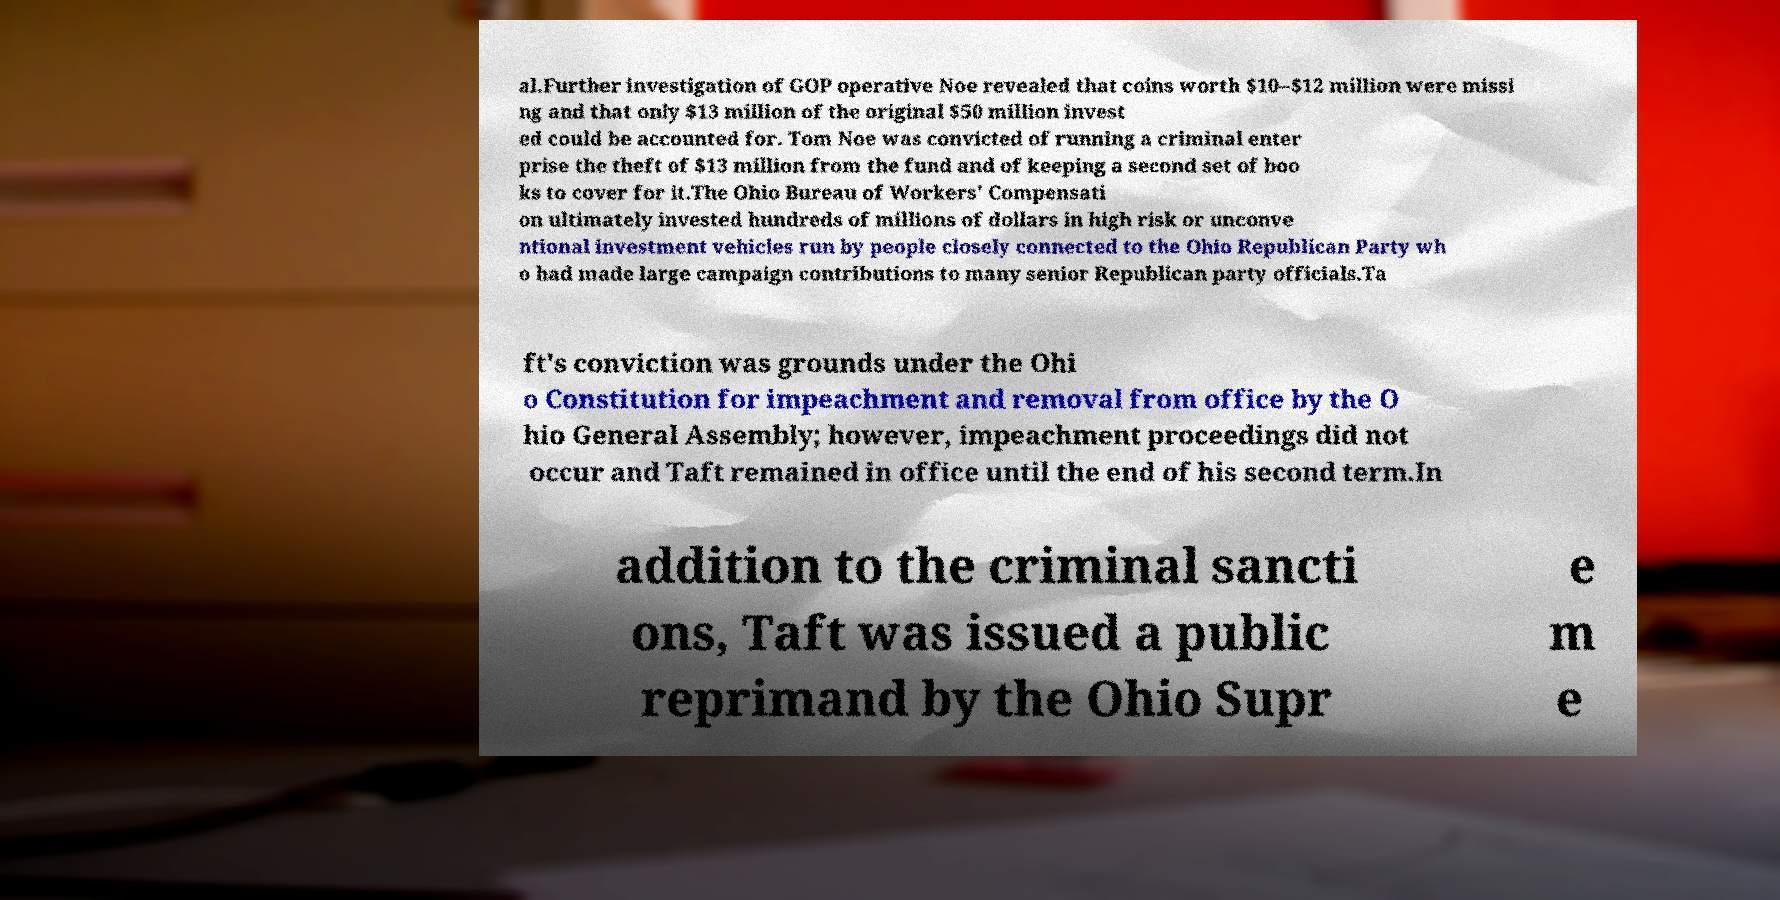Can you read and provide the text displayed in the image?This photo seems to have some interesting text. Can you extract and type it out for me? al.Further investigation of GOP operative Noe revealed that coins worth $10–$12 million were missi ng and that only $13 million of the original $50 million invest ed could be accounted for. Tom Noe was convicted of running a criminal enter prise the theft of $13 million from the fund and of keeping a second set of boo ks to cover for it.The Ohio Bureau of Workers' Compensati on ultimately invested hundreds of millions of dollars in high risk or unconve ntional investment vehicles run by people closely connected to the Ohio Republican Party wh o had made large campaign contributions to many senior Republican party officials.Ta ft's conviction was grounds under the Ohi o Constitution for impeachment and removal from office by the O hio General Assembly; however, impeachment proceedings did not occur and Taft remained in office until the end of his second term.In addition to the criminal sancti ons, Taft was issued a public reprimand by the Ohio Supr e m e 